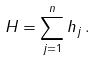Convert formula to latex. <formula><loc_0><loc_0><loc_500><loc_500>H = \sum _ { j = 1 } ^ { n } h _ { j } \, .</formula> 